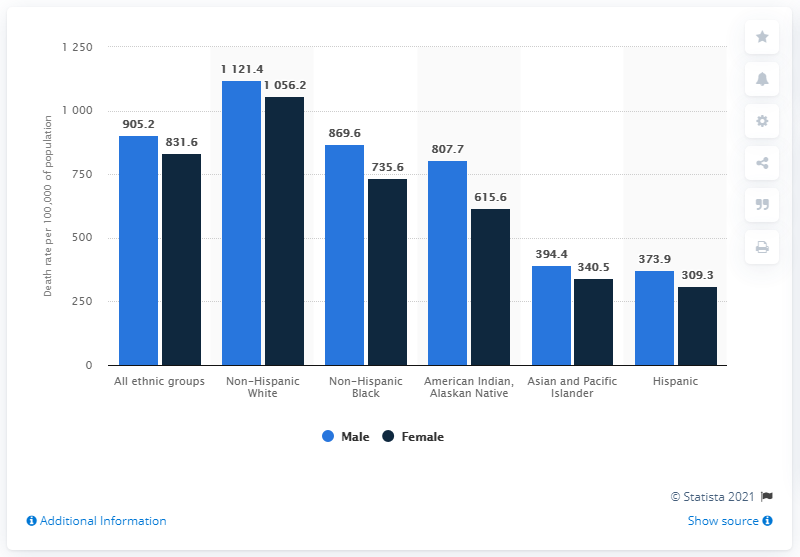Mention a couple of crucial points in this snapshot. In 2018, approximately 373.9 men of Hispanic origin lost their lives in the United States. In the Hispanic population, the death rate is higher for males than for females. The difference between the highest male and lowest female values in all groups is 812.1. 